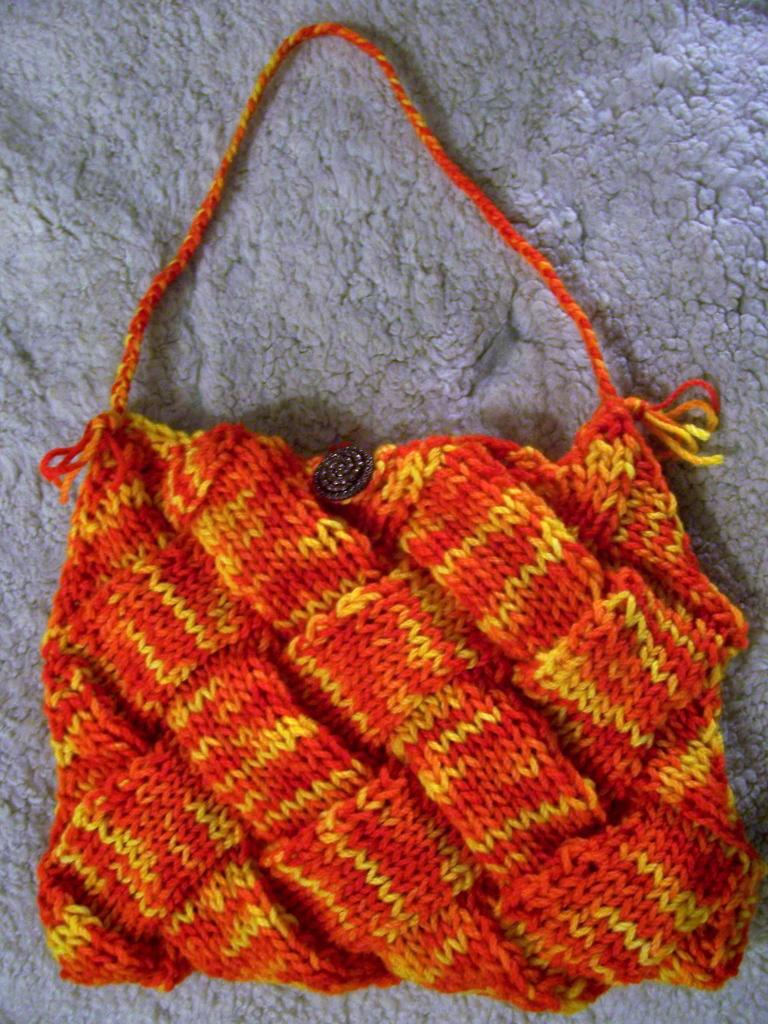What object can be seen in the image? There is a bag in the image. What is the color of the bag? The bag is red in color. How many books can be seen inside the bag in the image? There is no information about books or their presence inside the bag in the image. 